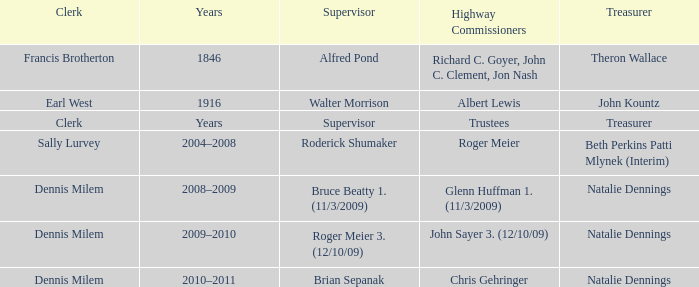When Treasurer was treasurer, who was the highway commissioner? Trustees. 